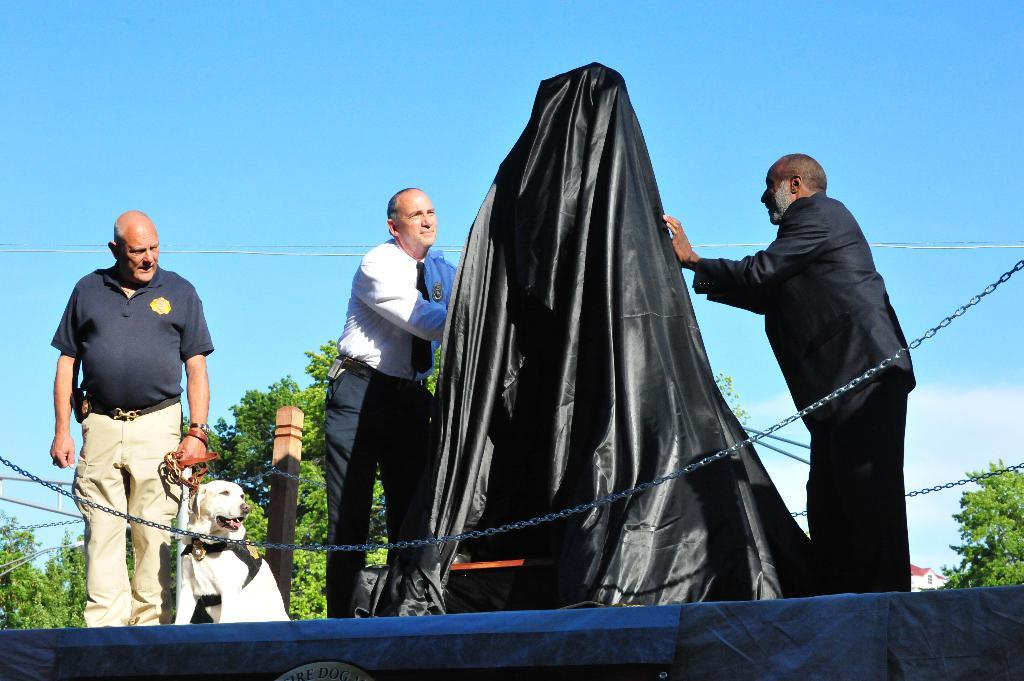What are the two persons holding in the image? They are holding a black cloth. Can you describe the clothing of one of the persons in the image? There is a person wearing a blue shirt. What is the person in the blue shirt holding? The person in the blue shirt is holding a dog. Where is the dog located in the image? The dog is in the left corner of the image. What type of gun is the person in the blue shirt holding in the image? There is no gun present in the image; the person in the blue shirt is holding a dog. What title is written on the tray in the image? There is no tray present in the image, so there is no title to describe. 